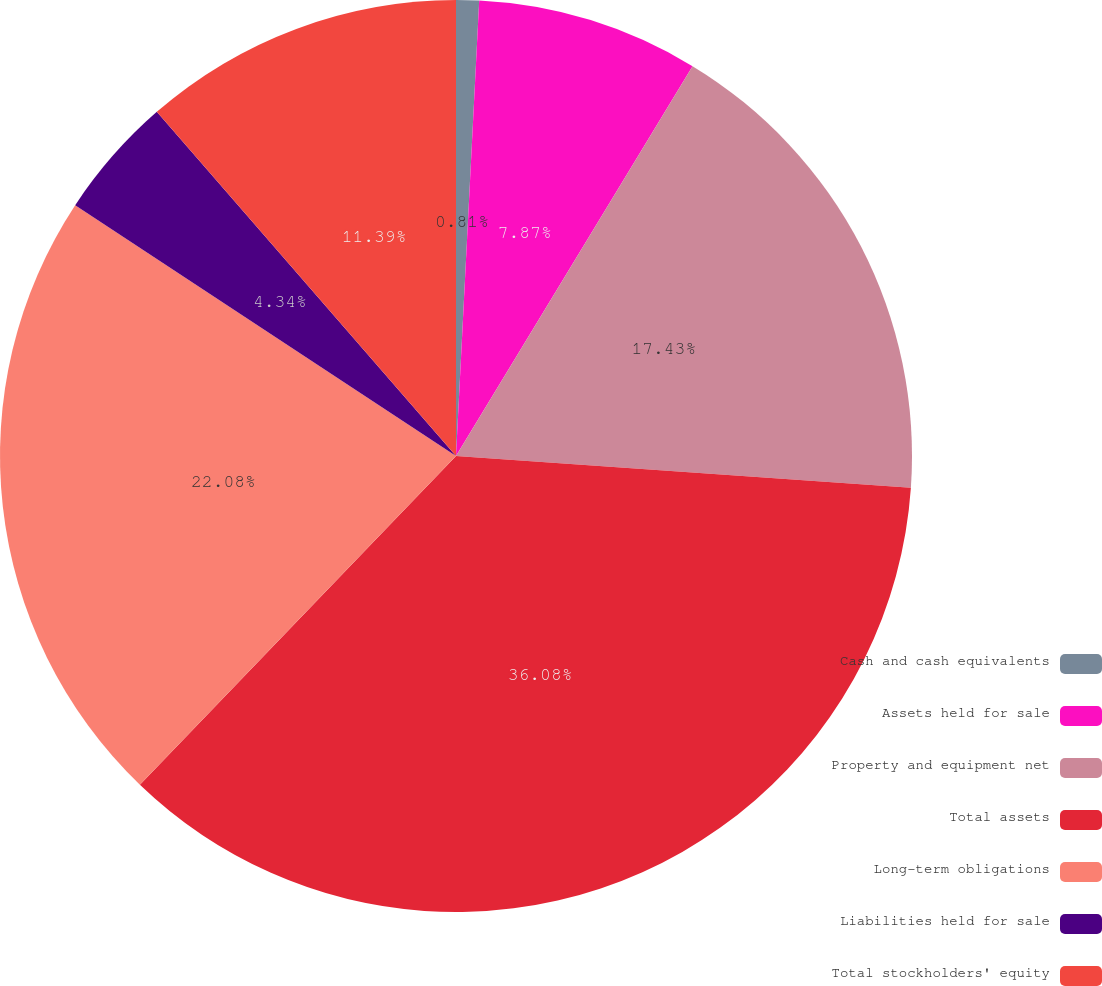Convert chart. <chart><loc_0><loc_0><loc_500><loc_500><pie_chart><fcel>Cash and cash equivalents<fcel>Assets held for sale<fcel>Property and equipment net<fcel>Total assets<fcel>Long-term obligations<fcel>Liabilities held for sale<fcel>Total stockholders' equity<nl><fcel>0.81%<fcel>7.87%<fcel>17.43%<fcel>36.08%<fcel>22.08%<fcel>4.34%<fcel>11.39%<nl></chart> 